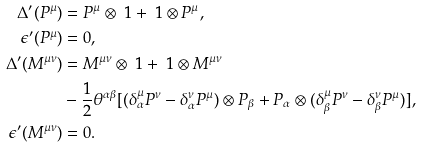<formula> <loc_0><loc_0><loc_500><loc_500>\Delta ^ { \prime } ( P ^ { \mu } ) & = P ^ { \mu } \otimes \ 1 + \ 1 \otimes P ^ { \mu } , \\ \epsilon ^ { \prime } ( P ^ { \mu } ) & = 0 , \\ \Delta ^ { \prime } ( M ^ { \mu \nu } ) & = M ^ { \mu \nu } \otimes \ 1 + \ 1 \otimes M ^ { \mu \nu } \\ & - \frac { 1 } { 2 } \theta ^ { \alpha \beta } [ ( \delta _ { \alpha } ^ { \mu } P ^ { \nu } - \delta _ { \alpha } ^ { \nu } P ^ { \mu } ) \otimes P _ { \beta } + P _ { \alpha } \otimes ( \delta _ { \beta } ^ { \mu } P ^ { \nu } - \delta _ { \beta } ^ { \nu } P ^ { \mu } ) ] , \\ \epsilon ^ { \prime } ( M ^ { \mu \nu } ) & = 0 .</formula> 